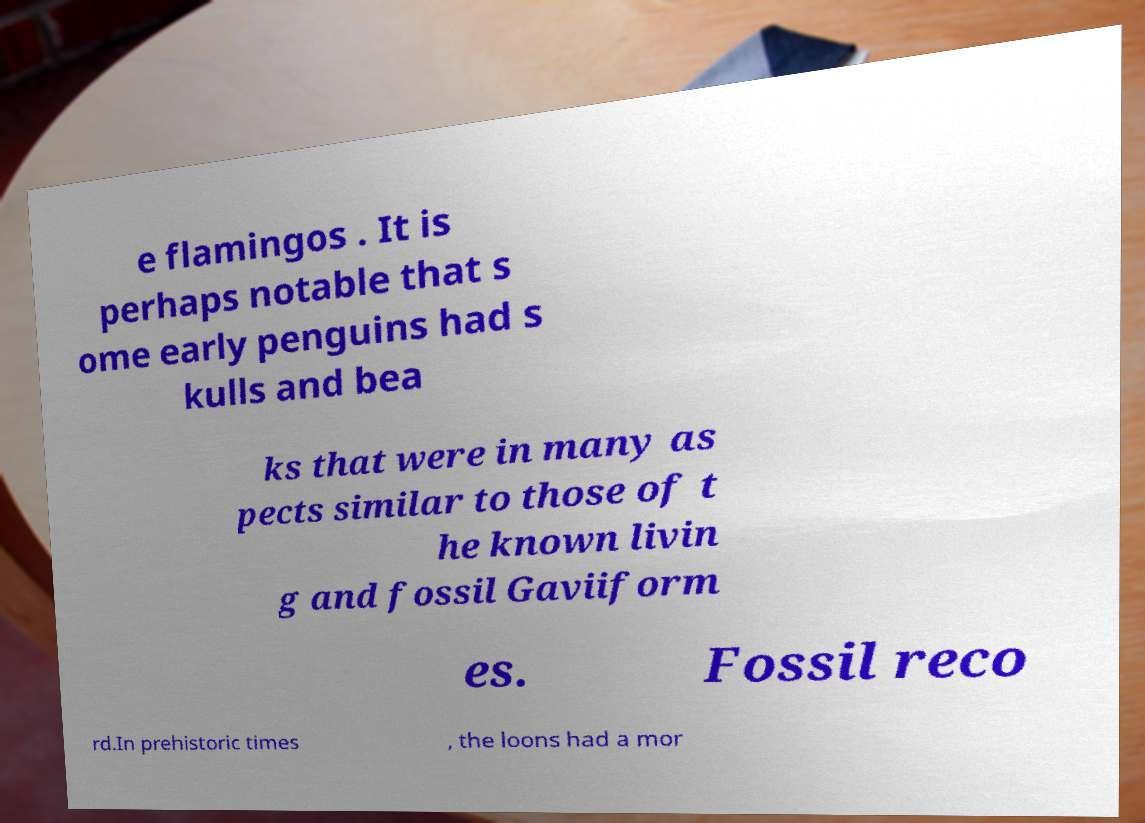What messages or text are displayed in this image? I need them in a readable, typed format. e flamingos . It is perhaps notable that s ome early penguins had s kulls and bea ks that were in many as pects similar to those of t he known livin g and fossil Gaviiform es. Fossil reco rd.In prehistoric times , the loons had a mor 